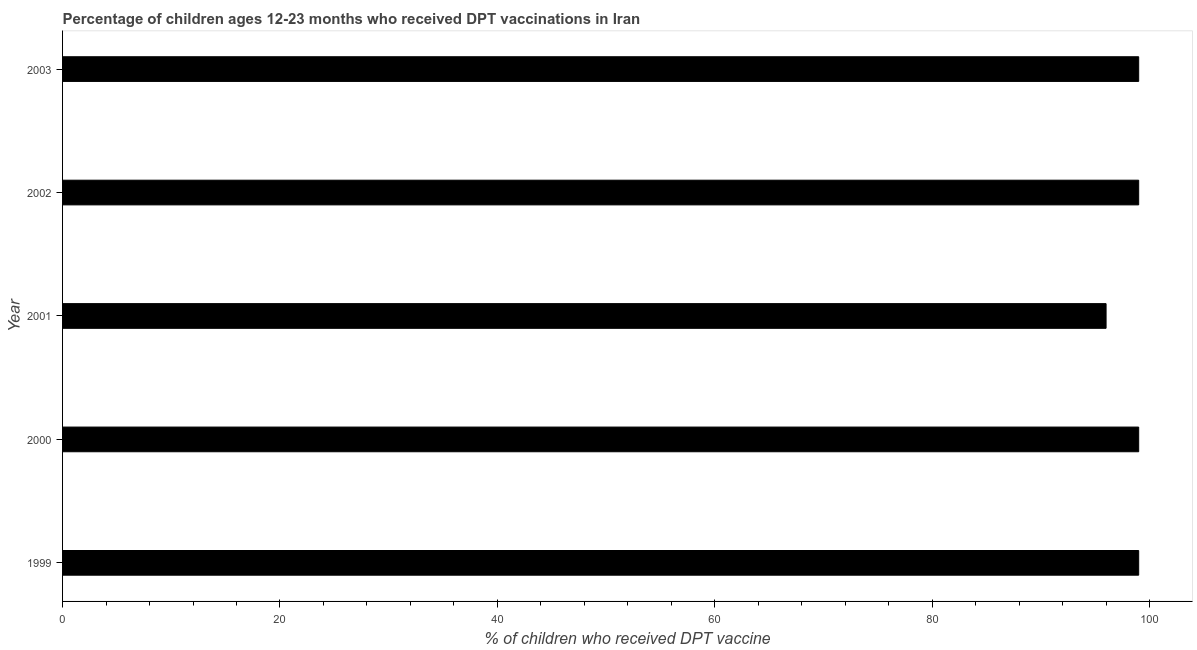Does the graph contain any zero values?
Give a very brief answer. No. Does the graph contain grids?
Offer a terse response. No. What is the title of the graph?
Your answer should be compact. Percentage of children ages 12-23 months who received DPT vaccinations in Iran. What is the label or title of the X-axis?
Provide a succinct answer. % of children who received DPT vaccine. What is the percentage of children who received dpt vaccine in 2001?
Make the answer very short. 96. Across all years, what is the maximum percentage of children who received dpt vaccine?
Your response must be concise. 99. Across all years, what is the minimum percentage of children who received dpt vaccine?
Make the answer very short. 96. In which year was the percentage of children who received dpt vaccine minimum?
Your answer should be compact. 2001. What is the sum of the percentage of children who received dpt vaccine?
Make the answer very short. 492. In how many years, is the percentage of children who received dpt vaccine greater than 80 %?
Ensure brevity in your answer.  5. Do a majority of the years between 1999 and 2003 (inclusive) have percentage of children who received dpt vaccine greater than 8 %?
Your response must be concise. Yes. What is the ratio of the percentage of children who received dpt vaccine in 1999 to that in 2003?
Your response must be concise. 1. Is the sum of the percentage of children who received dpt vaccine in 1999 and 2000 greater than the maximum percentage of children who received dpt vaccine across all years?
Offer a very short reply. Yes. In how many years, is the percentage of children who received dpt vaccine greater than the average percentage of children who received dpt vaccine taken over all years?
Provide a succinct answer. 4. How many bars are there?
Keep it short and to the point. 5. Are all the bars in the graph horizontal?
Give a very brief answer. Yes. What is the difference between two consecutive major ticks on the X-axis?
Keep it short and to the point. 20. Are the values on the major ticks of X-axis written in scientific E-notation?
Ensure brevity in your answer.  No. What is the % of children who received DPT vaccine in 1999?
Ensure brevity in your answer.  99. What is the % of children who received DPT vaccine in 2001?
Provide a succinct answer. 96. What is the % of children who received DPT vaccine of 2002?
Make the answer very short. 99. What is the difference between the % of children who received DPT vaccine in 1999 and 2000?
Offer a terse response. 0. What is the difference between the % of children who received DPT vaccine in 1999 and 2001?
Offer a terse response. 3. What is the difference between the % of children who received DPT vaccine in 2000 and 2003?
Offer a terse response. 0. What is the difference between the % of children who received DPT vaccine in 2001 and 2003?
Your response must be concise. -3. What is the ratio of the % of children who received DPT vaccine in 1999 to that in 2001?
Ensure brevity in your answer.  1.03. What is the ratio of the % of children who received DPT vaccine in 1999 to that in 2002?
Your response must be concise. 1. What is the ratio of the % of children who received DPT vaccine in 1999 to that in 2003?
Ensure brevity in your answer.  1. What is the ratio of the % of children who received DPT vaccine in 2000 to that in 2001?
Your answer should be compact. 1.03. What is the ratio of the % of children who received DPT vaccine in 2000 to that in 2002?
Make the answer very short. 1. What is the ratio of the % of children who received DPT vaccine in 2000 to that in 2003?
Your answer should be compact. 1. What is the ratio of the % of children who received DPT vaccine in 2001 to that in 2003?
Your response must be concise. 0.97. 